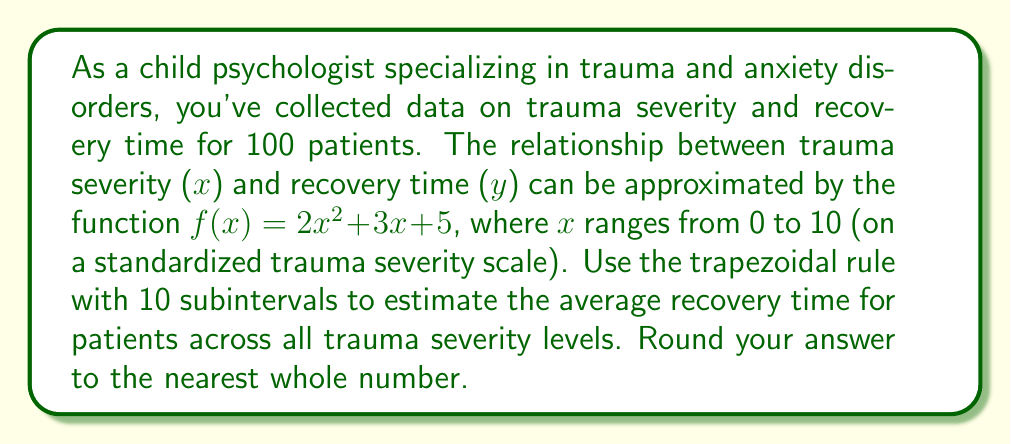Solve this math problem. To solve this problem, we'll use the trapezoidal rule for numerical integration:

1) The trapezoidal rule is given by:
   $$\int_{a}^{b} f(x) dx \approx \frac{h}{2}[f(x_0) + 2f(x_1) + 2f(x_2) + ... + 2f(x_{n-1}) + f(x_n)]$$
   where $h = \frac{b-a}{n}$, and $n$ is the number of subintervals.

2) In this case, $a=0$, $b=10$, and $n=10$. So, $h = \frac{10-0}{10} = 1$.

3) We need to calculate $f(x)$ for $x = 0, 1, 2, ..., 10$:
   $f(0) = 2(0)^2 + 3(0) + 5 = 5$
   $f(1) = 2(1)^2 + 3(1) + 5 = 10$
   $f(2) = 2(2)^2 + 3(2) + 5 = 19$
   ...
   $f(10) = 2(10)^2 + 3(10) + 5 = 235$

4) Applying the trapezoidal rule:
   $$\int_{0}^{10} f(x) dx \approx \frac{1}{2}[5 + 2(10 + 19 + 32 + 49 + 70 + 95 + 124 + 157 + 194) + 235]$$

5) Simplifying:
   $$\int_{0}^{10} f(x) dx \approx \frac{1}{2}[5 + 2(750) + 235] = \frac{1}{2}[1740] = 870$$

6) To find the average, we divide by the range (10):
   Average $\approx \frac{870}{10} = 87$

Therefore, the estimated average recovery time across all trauma severity levels is 87 (rounded to the nearest whole number).
Answer: 87 